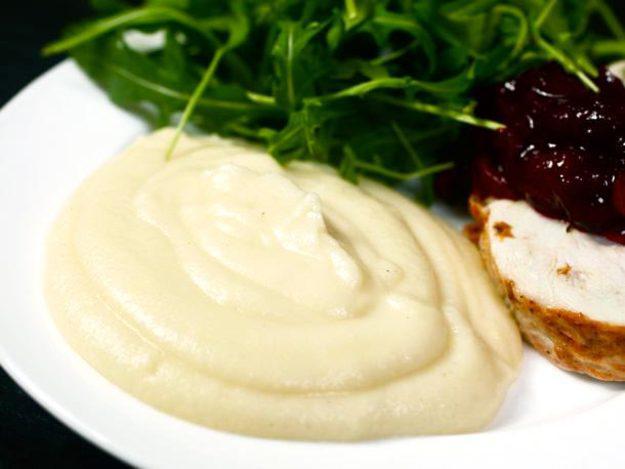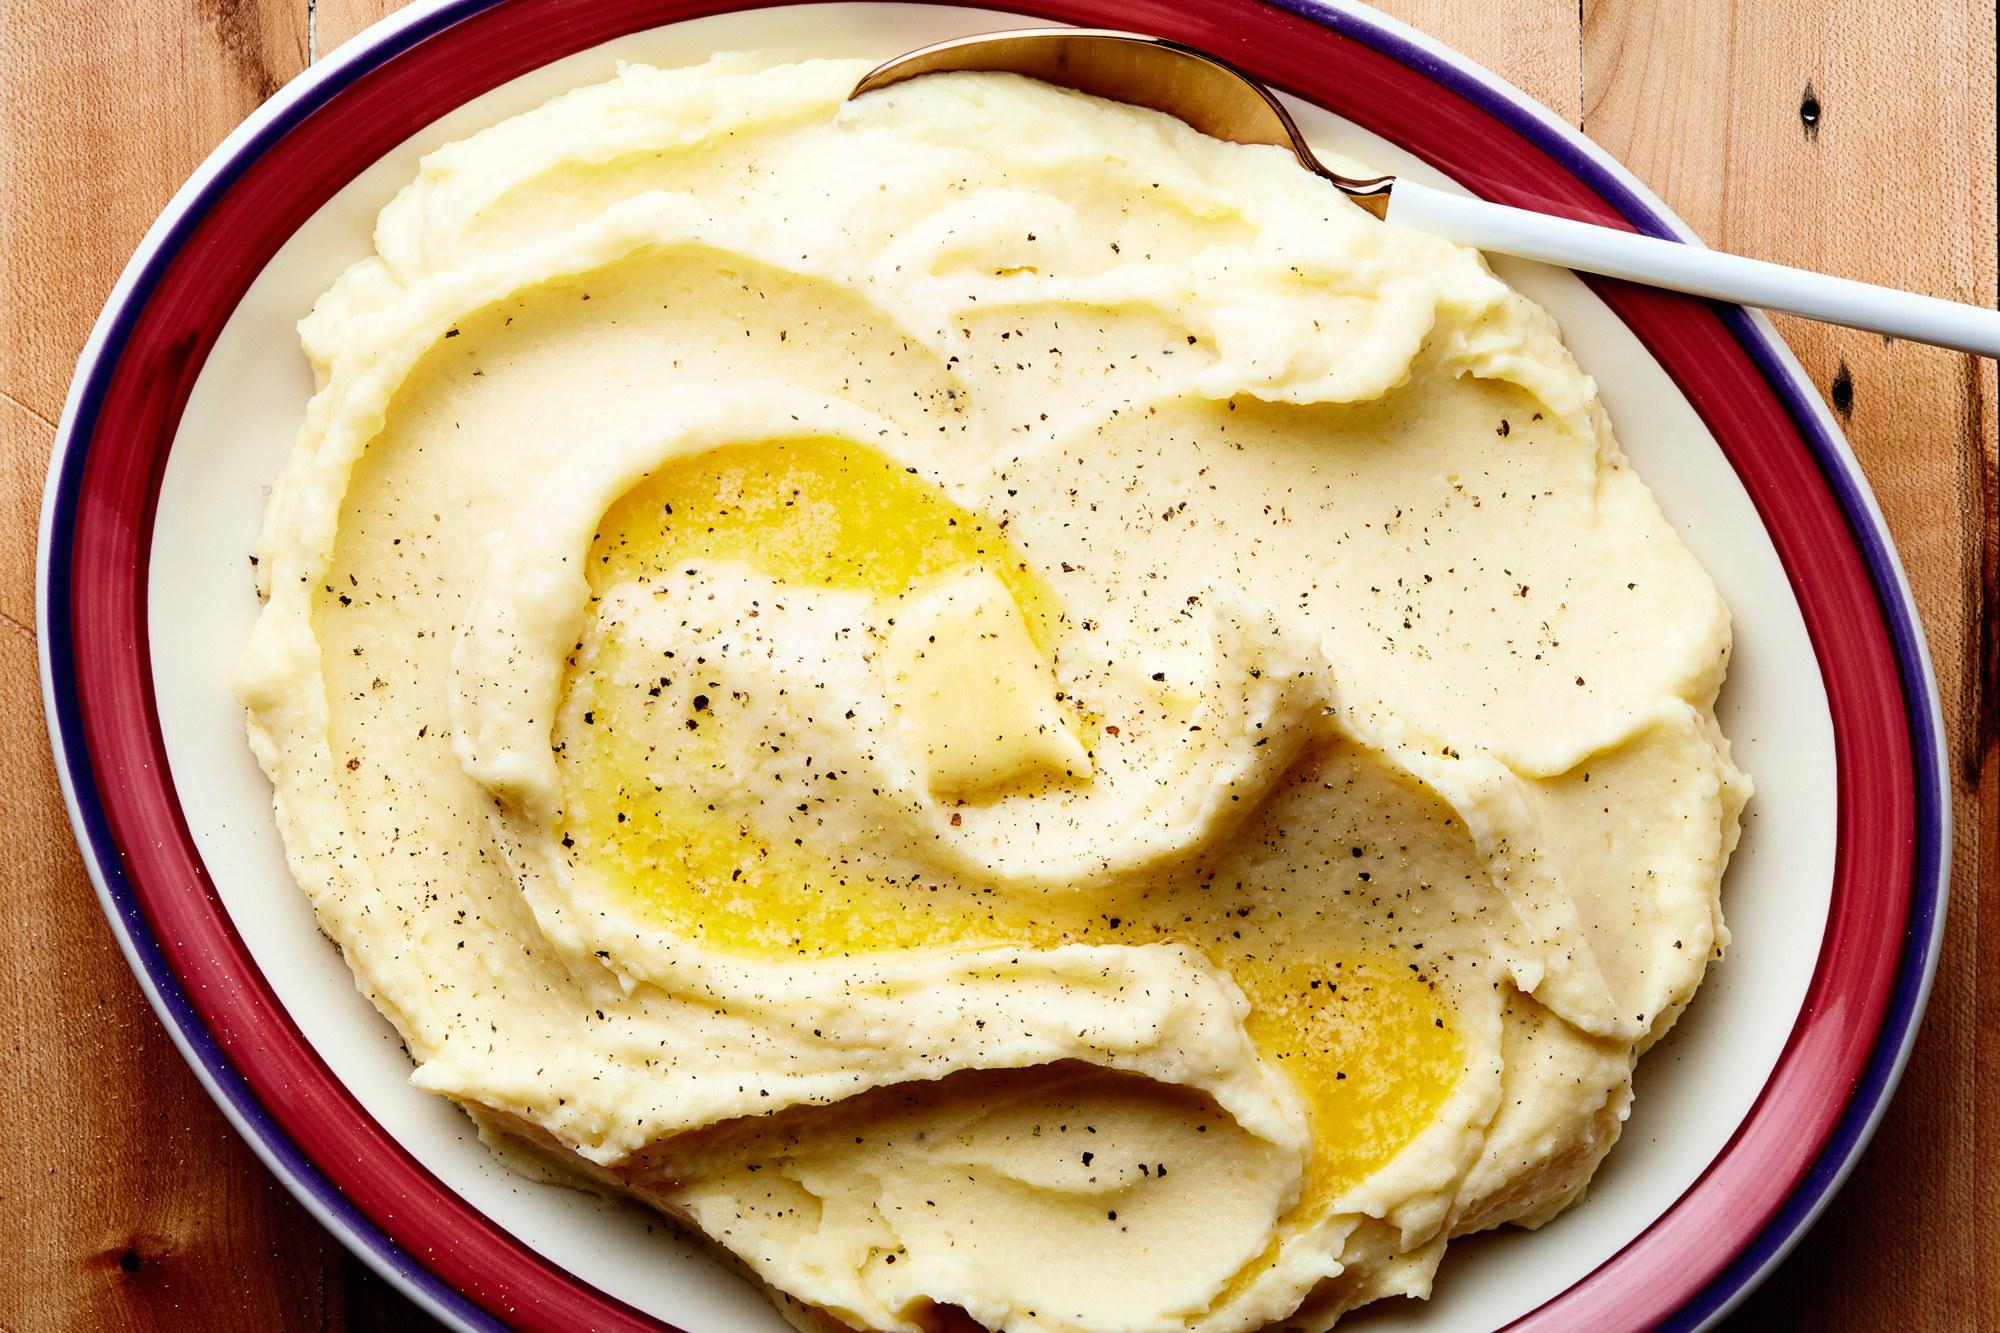The first image is the image on the left, the second image is the image on the right. Given the left and right images, does the statement "An image shows a spoon next to a dish." hold true? Answer yes or no. No. The first image is the image on the left, the second image is the image on the right. Given the left and right images, does the statement "There is a utensil in the food in the image on the left." hold true? Answer yes or no. No. 